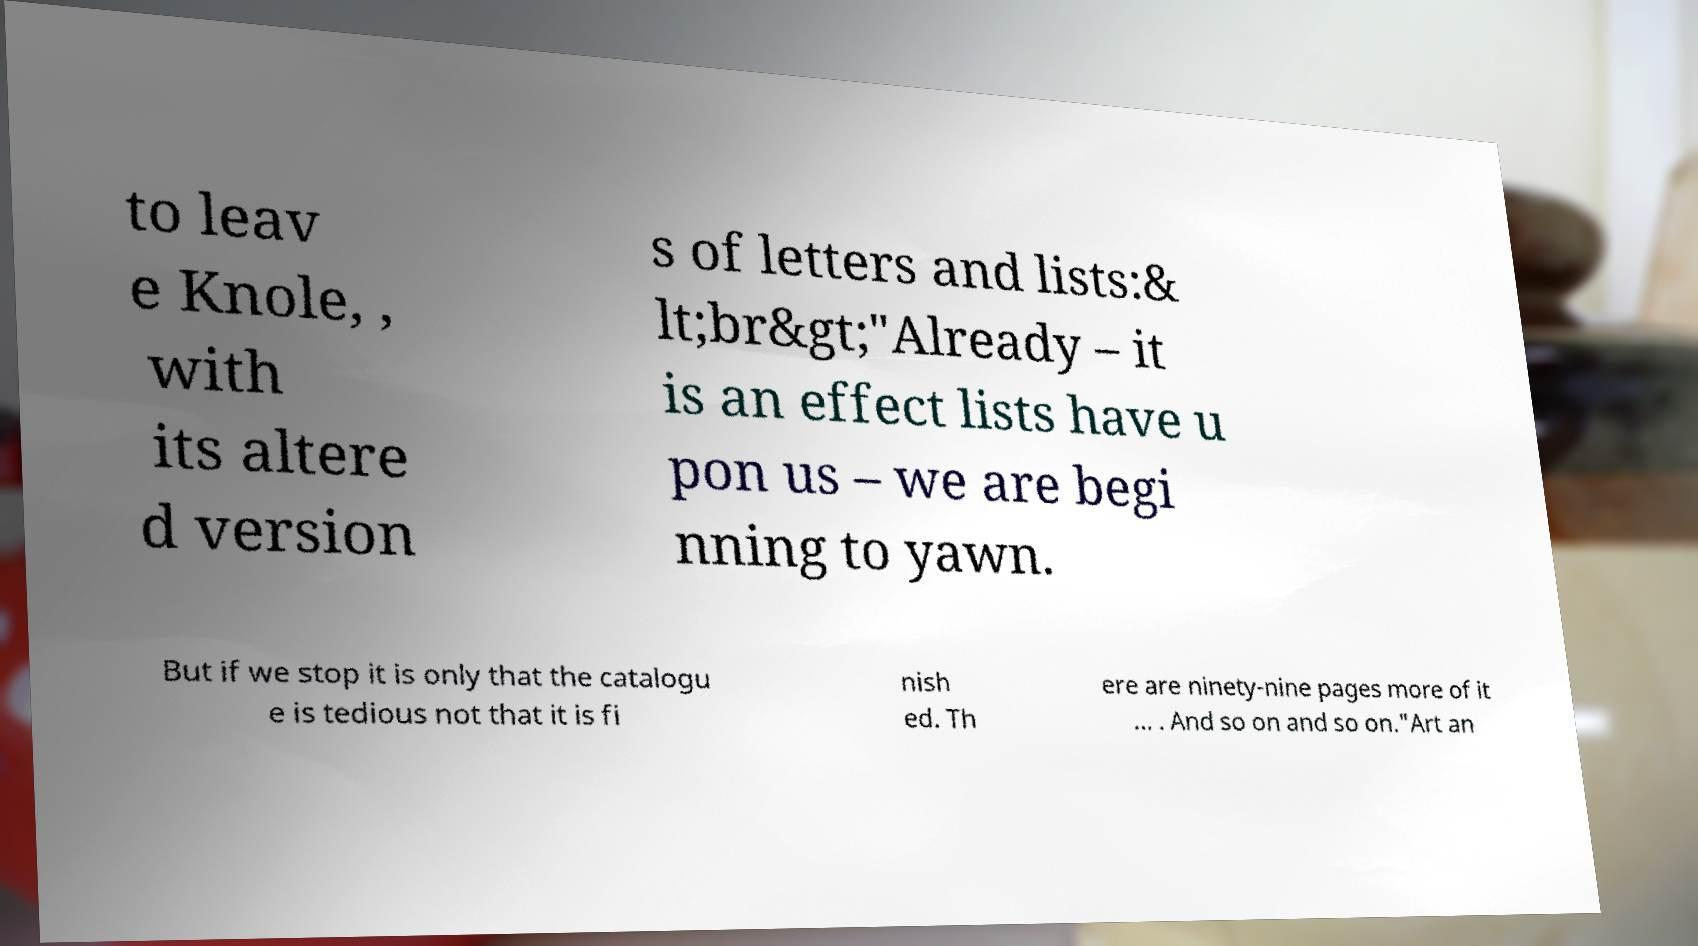Could you assist in decoding the text presented in this image and type it out clearly? to leav e Knole, , with its altere d version s of letters and lists:& lt;br&gt;"Already – it is an effect lists have u pon us – we are begi nning to yawn. But if we stop it is only that the catalogu e is tedious not that it is fi nish ed. Th ere are ninety-nine pages more of it … . And so on and so on."Art an 